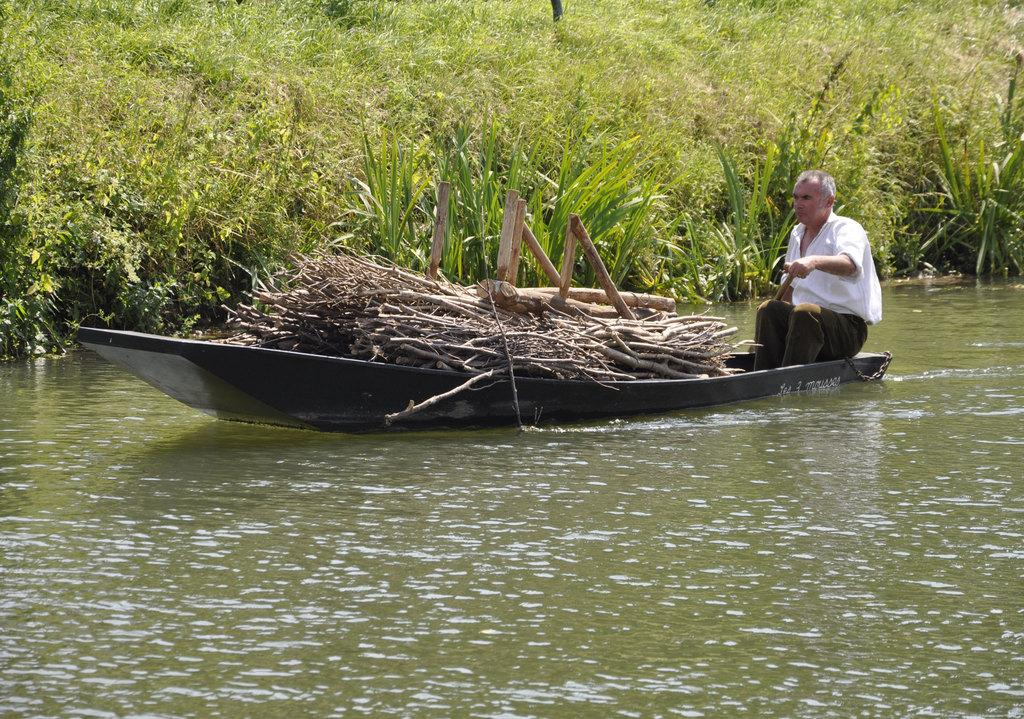What is in the foreground of the picture? There is a water body in the foreground of the picture. What is located in the water? There is a boat in the water. What can be found inside the boat? There are wooden logs in the boat. Who is present in the boat? There is a man in the boat. What can be seen in the background of the image? There are plants in the background of the image. What type of square structure can be seen in the image? There is no square structure present in the image; it features a water body, a boat, wooden logs, a man, and plants. 